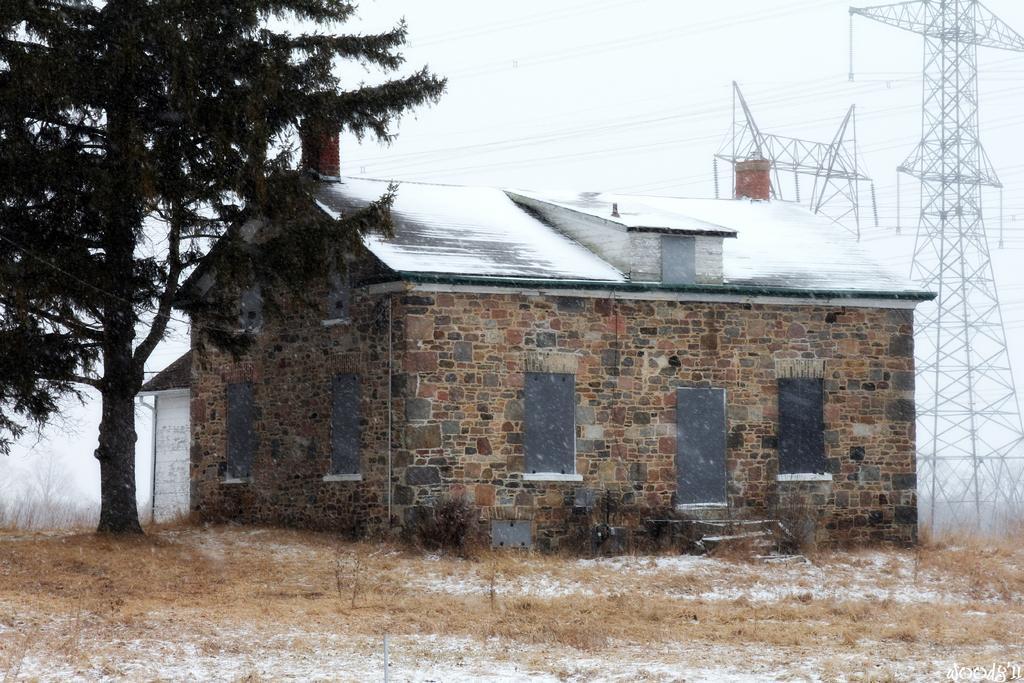How would you summarize this image in a sentence or two? In this picture we can see dried grass on the ground and in the background we can see sheds, poles, tree, sky. 